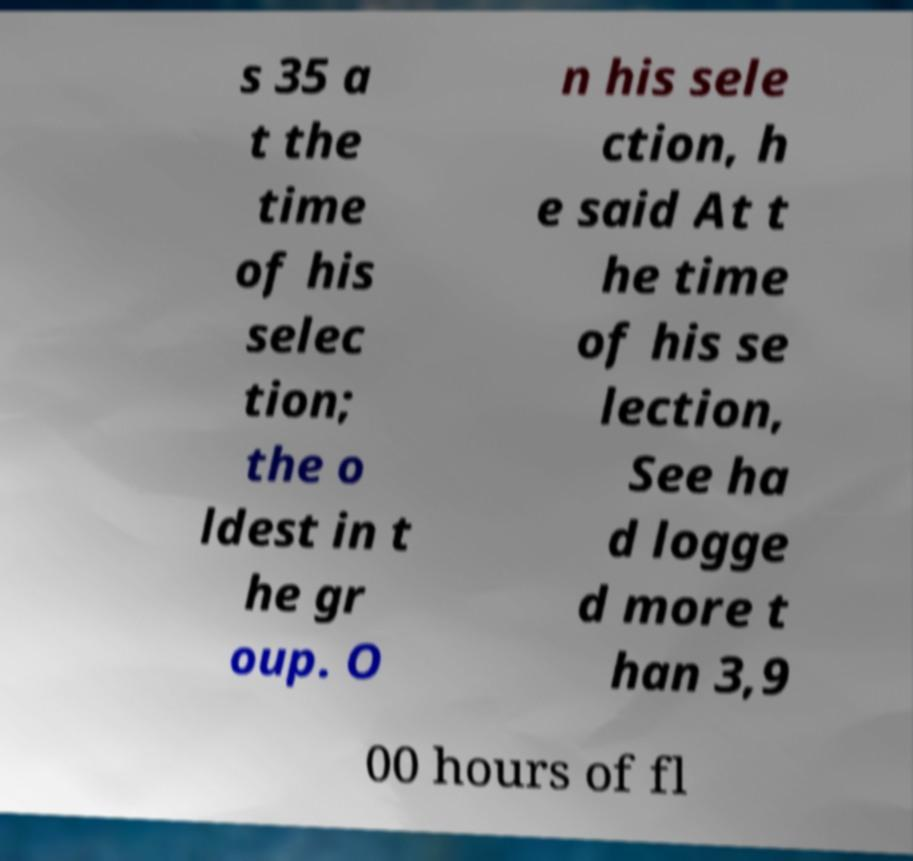For documentation purposes, I need the text within this image transcribed. Could you provide that? s 35 a t the time of his selec tion; the o ldest in t he gr oup. O n his sele ction, h e said At t he time of his se lection, See ha d logge d more t han 3,9 00 hours of fl 